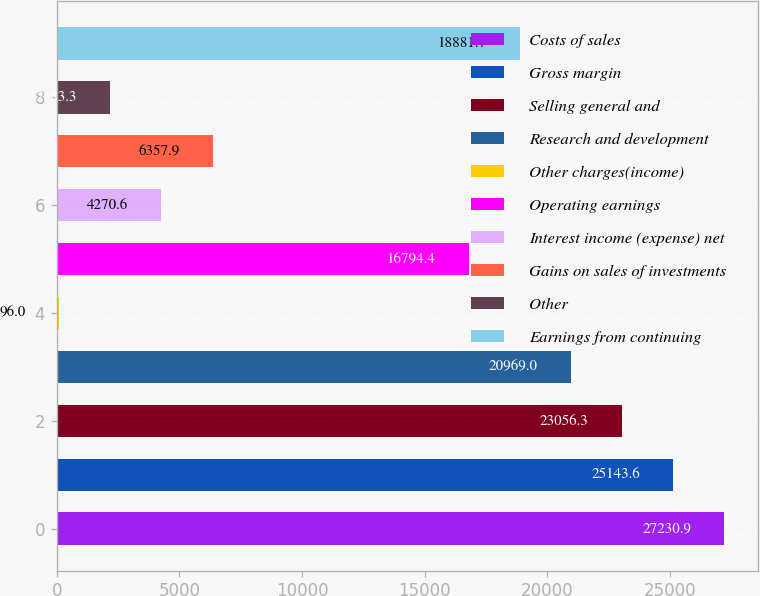Convert chart. <chart><loc_0><loc_0><loc_500><loc_500><bar_chart><fcel>Costs of sales<fcel>Gross margin<fcel>Selling general and<fcel>Research and development<fcel>Other charges(income)<fcel>Operating earnings<fcel>Interest income (expense) net<fcel>Gains on sales of investments<fcel>Other<fcel>Earnings from continuing<nl><fcel>27230.9<fcel>25143.6<fcel>23056.3<fcel>20969<fcel>96<fcel>16794.4<fcel>4270.6<fcel>6357.9<fcel>2183.3<fcel>18881.7<nl></chart> 